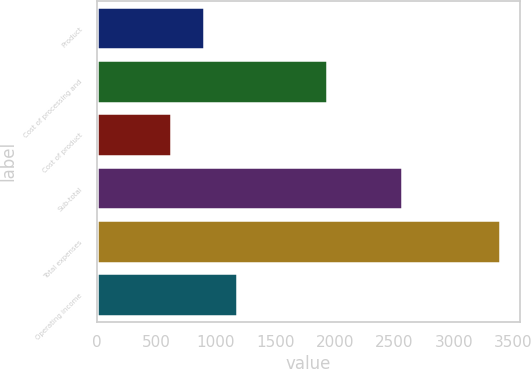<chart> <loc_0><loc_0><loc_500><loc_500><bar_chart><fcel>Product<fcel>Cost of processing and<fcel>Cost of product<fcel>Sub-total<fcel>Total expenses<fcel>Operating income<nl><fcel>904<fcel>1936<fcel>628<fcel>2564<fcel>3388<fcel>1180<nl></chart> 